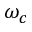<formula> <loc_0><loc_0><loc_500><loc_500>\omega _ { c }</formula> 